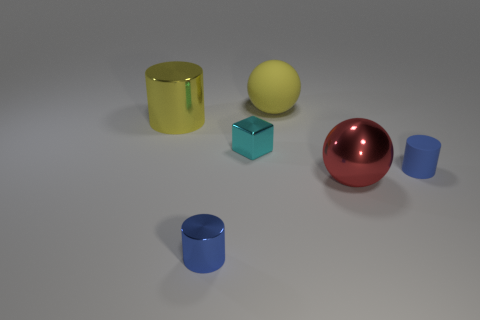Add 4 small objects. How many objects exist? 10 Subtract all blocks. How many objects are left? 5 Subtract 0 yellow cubes. How many objects are left? 6 Subtract all small brown matte spheres. Subtract all tiny cylinders. How many objects are left? 4 Add 6 metallic cylinders. How many metallic cylinders are left? 8 Add 4 yellow objects. How many yellow objects exist? 6 